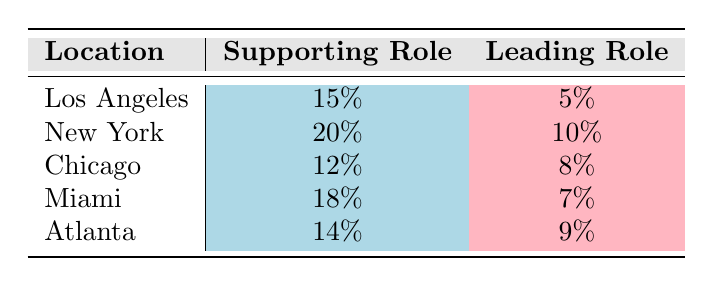What is the audition success rate for supporting roles in Los Angeles? From the table, the audition success rate for supporting roles in Los Angeles is explicitly given as 15%.
Answer: 15% Which location has the highest audition success rate for leading roles? By comparing the leading role success rates across locations, New York has the highest at 10%, higher than the other locations.
Answer: New York What is the difference in audition success rates for supporting roles between New York and Miami? The success rate for supporting roles in New York is 20% and in Miami it is 18%. The difference is 20% - 18% = 2%.
Answer: 2% Is the audition success rate for leading roles in Atlanta higher than in Chicago? The leading role success rate in Atlanta is 9% while in Chicago it is 8%. Since 9% is greater than 8%, the statement is true.
Answer: Yes What is the average audition success rate for supporting roles across all locations? To find the average, calculate the sum of the success rates for supporting roles (15% + 20% + 12% + 18% + 14% = 79%) and divide by 5 (the number of locations), which equals 79% / 5 = 15.8%.
Answer: 15.8% 